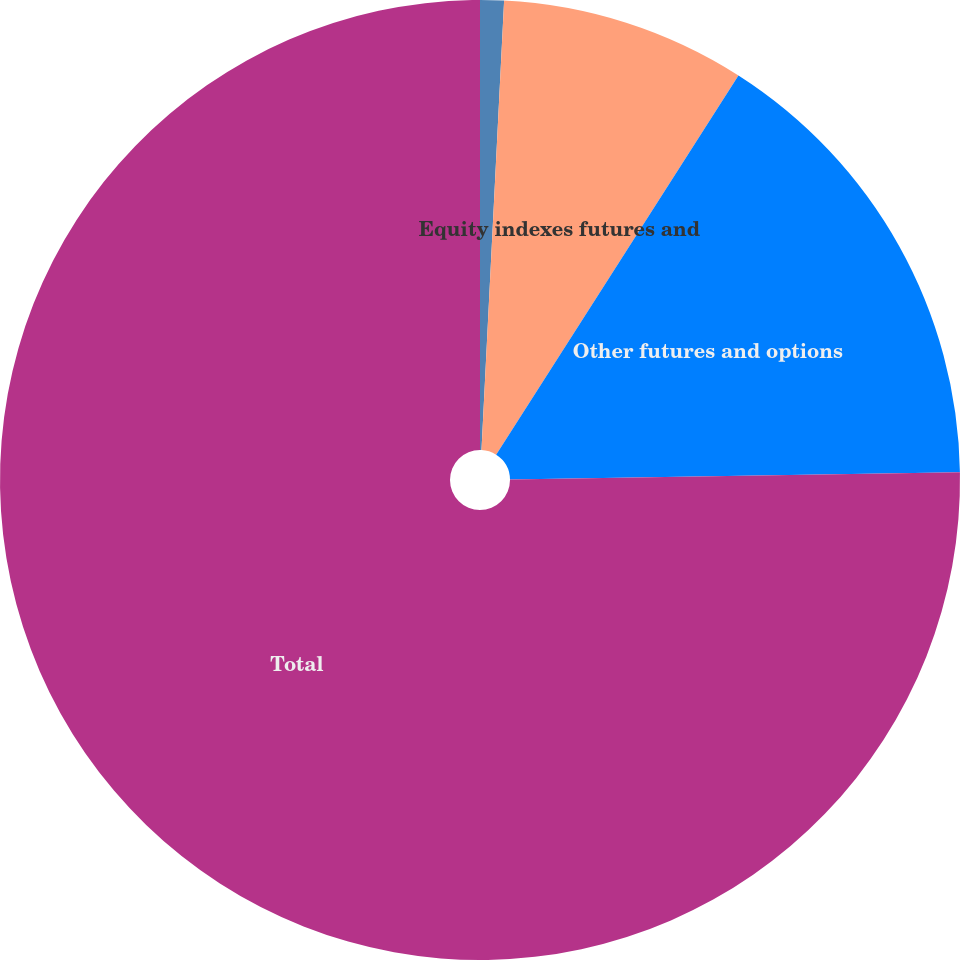<chart> <loc_0><loc_0><loc_500><loc_500><pie_chart><fcel>ICE emission futures and<fcel>Equity indexes futures and<fcel>Other futures and options<fcel>Total<nl><fcel>0.8%<fcel>8.25%<fcel>15.69%<fcel>75.26%<nl></chart> 